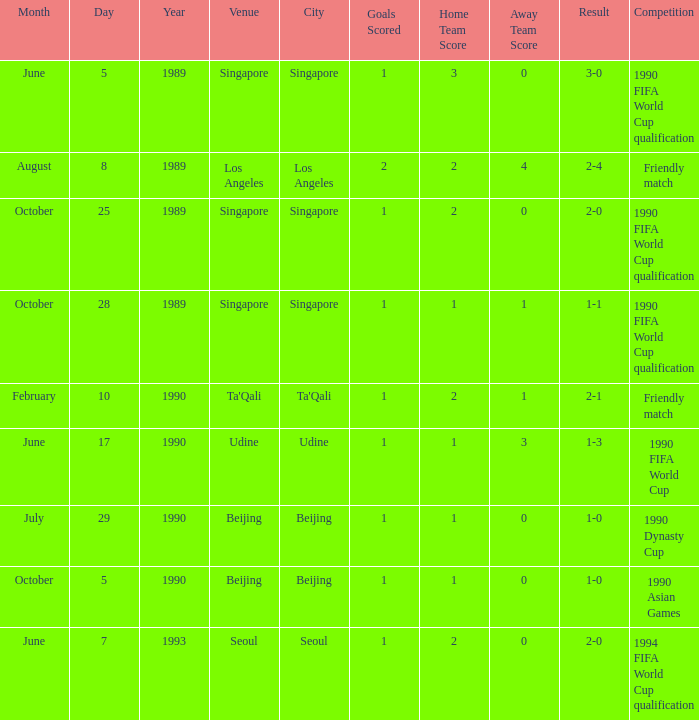At which location did the outcome end in a 2-1 score? Ta'Qali. 